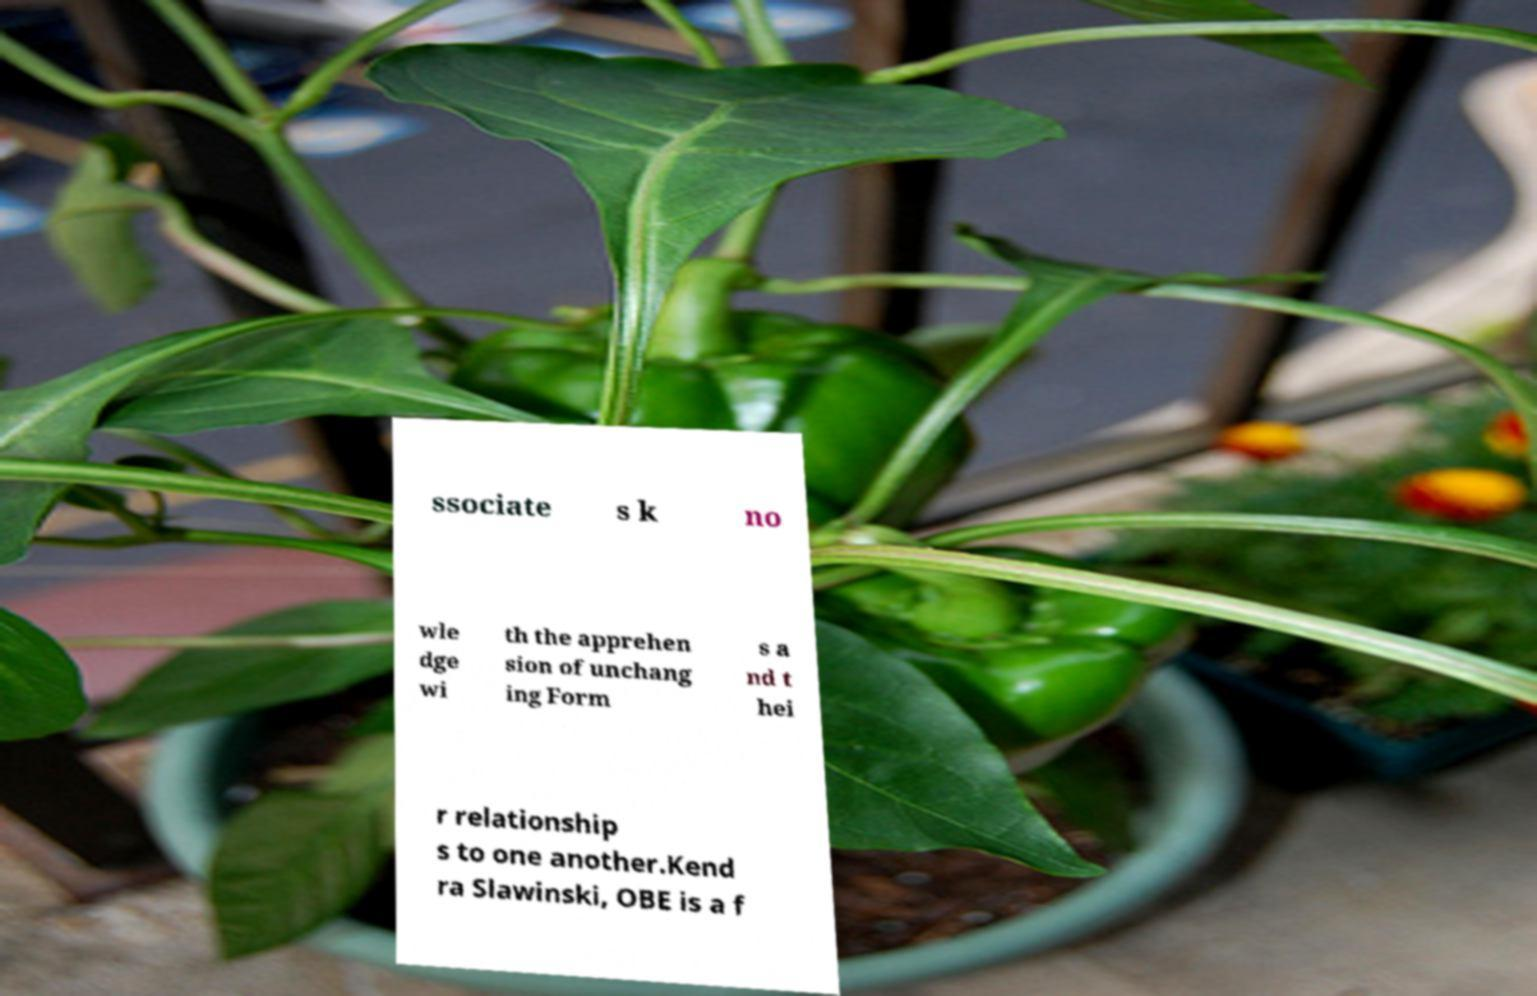Could you extract and type out the text from this image? ssociate s k no wle dge wi th the apprehen sion of unchang ing Form s a nd t hei r relationship s to one another.Kend ra Slawinski, OBE is a f 